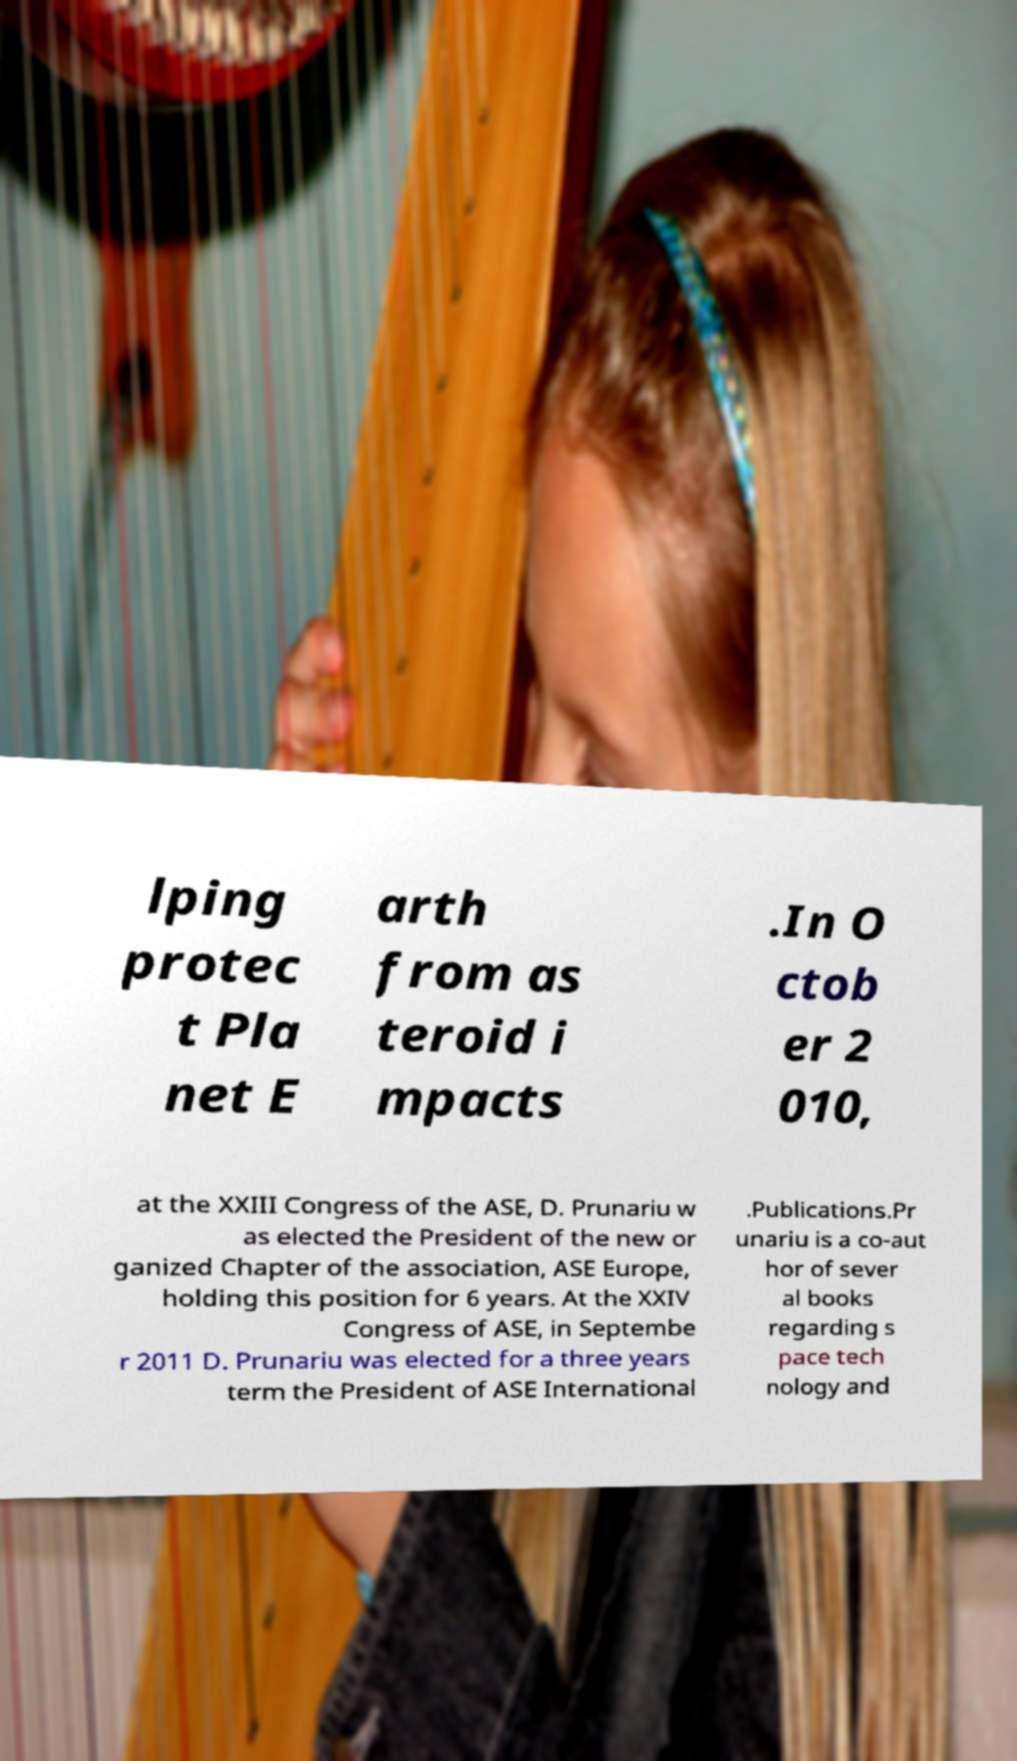What messages or text are displayed in this image? I need them in a readable, typed format. lping protec t Pla net E arth from as teroid i mpacts .In O ctob er 2 010, at the XXIII Congress of the ASE, D. Prunariu w as elected the President of the new or ganized Chapter of the association, ASE Europe, holding this position for 6 years. At the XXIV Congress of ASE, in Septembe r 2011 D. Prunariu was elected for a three years term the President of ASE International .Publications.Pr unariu is a co-aut hor of sever al books regarding s pace tech nology and 